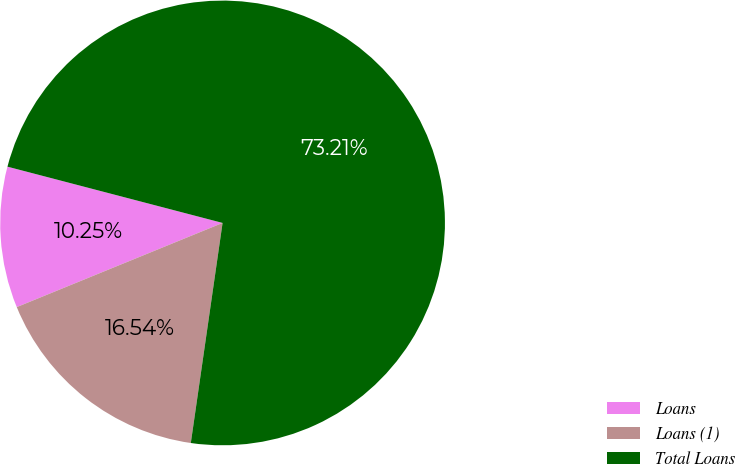Convert chart. <chart><loc_0><loc_0><loc_500><loc_500><pie_chart><fcel>Loans<fcel>Loans (1)<fcel>Total Loans<nl><fcel>10.25%<fcel>16.54%<fcel>73.21%<nl></chart> 